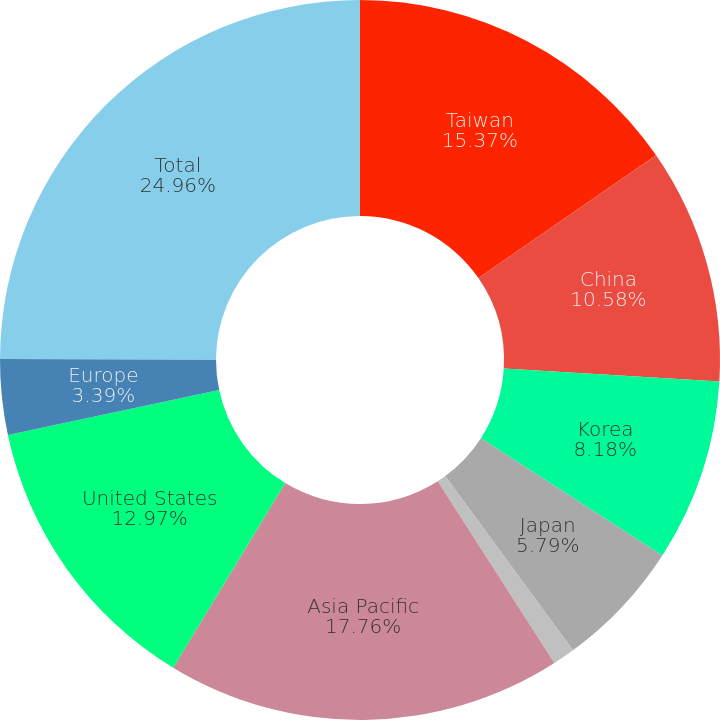Convert chart. <chart><loc_0><loc_0><loc_500><loc_500><pie_chart><fcel>Taiwan<fcel>China<fcel>Korea<fcel>Japan<fcel>Southeast Asia<fcel>Asia Pacific<fcel>United States<fcel>Europe<fcel>Total<nl><fcel>15.37%<fcel>10.58%<fcel>8.18%<fcel>5.79%<fcel>1.0%<fcel>17.76%<fcel>12.97%<fcel>3.39%<fcel>24.95%<nl></chart> 